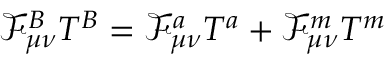Convert formula to latex. <formula><loc_0><loc_0><loc_500><loc_500>\mathcal { F } _ { \mu \nu } ^ { B } T ^ { B } = \mathcal { F } _ { \mu \nu } ^ { a } T ^ { a } + \mathcal { F } _ { \mu \nu } ^ { m } T ^ { m }</formula> 